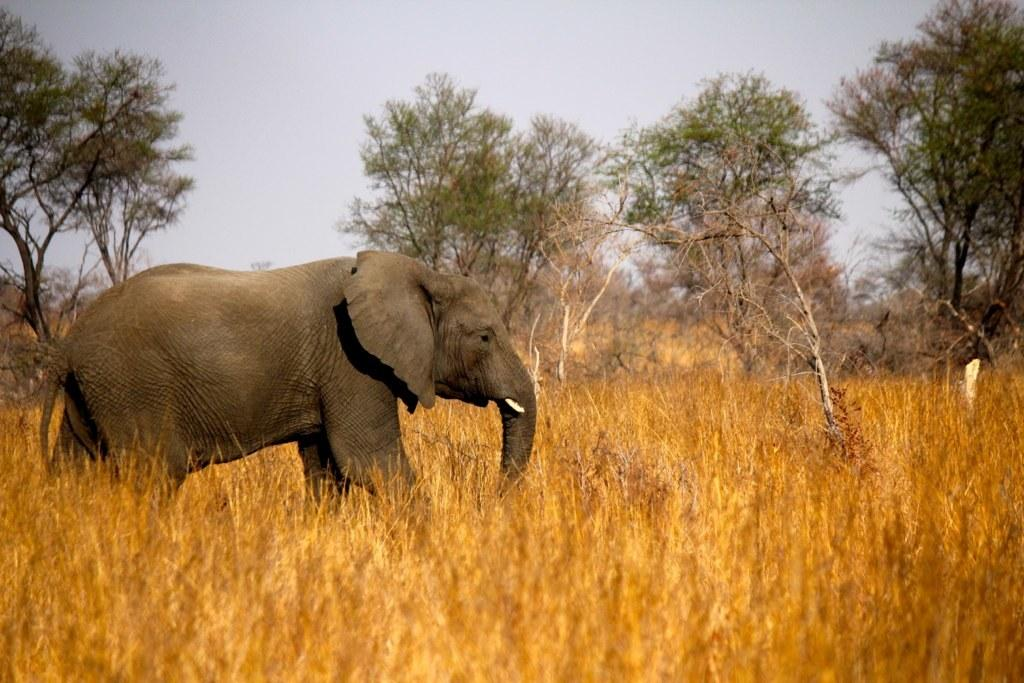What animal is the main subject of the image? There is an elephant in the image. What is the position of the elephant in the image? The elephant is standing in the image. Where is the elephant located in the image? The elephant is in the grass in the image. What can be seen in the background of the image? There are trees and a blue sky in the background of the image. What type of drug is the elephant taking in the image? There is no indication in the image that the elephant is taking any drug, and therefore no such activity can be observed. 